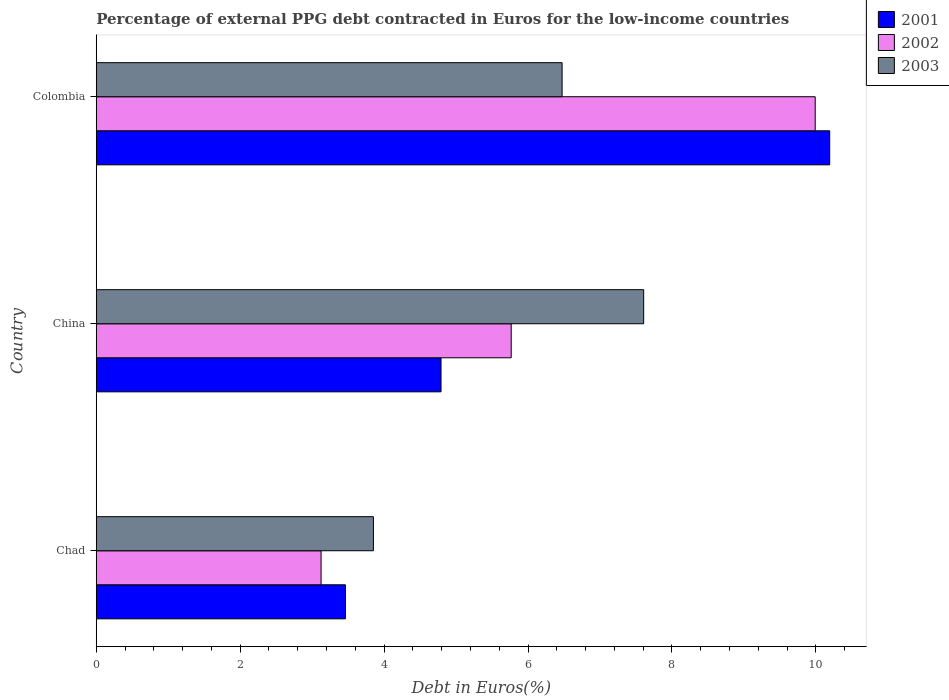Are the number of bars per tick equal to the number of legend labels?
Give a very brief answer. Yes. What is the label of the 1st group of bars from the top?
Give a very brief answer. Colombia. What is the percentage of external PPG debt contracted in Euros in 2003 in China?
Offer a terse response. 7.61. Across all countries, what is the maximum percentage of external PPG debt contracted in Euros in 2002?
Offer a very short reply. 9.99. Across all countries, what is the minimum percentage of external PPG debt contracted in Euros in 2001?
Your answer should be very brief. 3.46. In which country was the percentage of external PPG debt contracted in Euros in 2002 maximum?
Give a very brief answer. Colombia. In which country was the percentage of external PPG debt contracted in Euros in 2003 minimum?
Your response must be concise. Chad. What is the total percentage of external PPG debt contracted in Euros in 2002 in the graph?
Your response must be concise. 18.88. What is the difference between the percentage of external PPG debt contracted in Euros in 2003 in Chad and that in China?
Your answer should be very brief. -3.76. What is the difference between the percentage of external PPG debt contracted in Euros in 2003 in China and the percentage of external PPG debt contracted in Euros in 2002 in Colombia?
Provide a succinct answer. -2.38. What is the average percentage of external PPG debt contracted in Euros in 2003 per country?
Provide a succinct answer. 5.98. What is the difference between the percentage of external PPG debt contracted in Euros in 2002 and percentage of external PPG debt contracted in Euros in 2001 in China?
Your answer should be compact. 0.98. What is the ratio of the percentage of external PPG debt contracted in Euros in 2003 in Chad to that in Colombia?
Your answer should be very brief. 0.59. What is the difference between the highest and the second highest percentage of external PPG debt contracted in Euros in 2001?
Provide a succinct answer. 5.4. What is the difference between the highest and the lowest percentage of external PPG debt contracted in Euros in 2003?
Make the answer very short. 3.76. In how many countries, is the percentage of external PPG debt contracted in Euros in 2002 greater than the average percentage of external PPG debt contracted in Euros in 2002 taken over all countries?
Provide a short and direct response. 1. Is the sum of the percentage of external PPG debt contracted in Euros in 2002 in Chad and Colombia greater than the maximum percentage of external PPG debt contracted in Euros in 2003 across all countries?
Offer a very short reply. Yes. Is it the case that in every country, the sum of the percentage of external PPG debt contracted in Euros in 2001 and percentage of external PPG debt contracted in Euros in 2003 is greater than the percentage of external PPG debt contracted in Euros in 2002?
Provide a succinct answer. Yes. How many countries are there in the graph?
Provide a short and direct response. 3. What is the difference between two consecutive major ticks on the X-axis?
Make the answer very short. 2. Does the graph contain grids?
Ensure brevity in your answer.  No. Where does the legend appear in the graph?
Provide a succinct answer. Top right. What is the title of the graph?
Keep it short and to the point. Percentage of external PPG debt contracted in Euros for the low-income countries. What is the label or title of the X-axis?
Keep it short and to the point. Debt in Euros(%). What is the label or title of the Y-axis?
Provide a short and direct response. Country. What is the Debt in Euros(%) in 2001 in Chad?
Make the answer very short. 3.46. What is the Debt in Euros(%) in 2002 in Chad?
Your answer should be compact. 3.12. What is the Debt in Euros(%) of 2003 in Chad?
Keep it short and to the point. 3.85. What is the Debt in Euros(%) of 2001 in China?
Make the answer very short. 4.79. What is the Debt in Euros(%) in 2002 in China?
Provide a short and direct response. 5.77. What is the Debt in Euros(%) of 2003 in China?
Offer a very short reply. 7.61. What is the Debt in Euros(%) of 2001 in Colombia?
Make the answer very short. 10.19. What is the Debt in Euros(%) in 2002 in Colombia?
Give a very brief answer. 9.99. What is the Debt in Euros(%) in 2003 in Colombia?
Provide a succinct answer. 6.47. Across all countries, what is the maximum Debt in Euros(%) in 2001?
Your response must be concise. 10.19. Across all countries, what is the maximum Debt in Euros(%) in 2002?
Offer a terse response. 9.99. Across all countries, what is the maximum Debt in Euros(%) of 2003?
Give a very brief answer. 7.61. Across all countries, what is the minimum Debt in Euros(%) of 2001?
Your response must be concise. 3.46. Across all countries, what is the minimum Debt in Euros(%) in 2002?
Keep it short and to the point. 3.12. Across all countries, what is the minimum Debt in Euros(%) in 2003?
Make the answer very short. 3.85. What is the total Debt in Euros(%) in 2001 in the graph?
Your response must be concise. 18.44. What is the total Debt in Euros(%) in 2002 in the graph?
Keep it short and to the point. 18.88. What is the total Debt in Euros(%) of 2003 in the graph?
Provide a short and direct response. 17.93. What is the difference between the Debt in Euros(%) of 2001 in Chad and that in China?
Offer a very short reply. -1.33. What is the difference between the Debt in Euros(%) of 2002 in Chad and that in China?
Ensure brevity in your answer.  -2.64. What is the difference between the Debt in Euros(%) in 2003 in Chad and that in China?
Your answer should be compact. -3.76. What is the difference between the Debt in Euros(%) in 2001 in Chad and that in Colombia?
Offer a very short reply. -6.73. What is the difference between the Debt in Euros(%) in 2002 in Chad and that in Colombia?
Your response must be concise. -6.87. What is the difference between the Debt in Euros(%) of 2003 in Chad and that in Colombia?
Provide a succinct answer. -2.62. What is the difference between the Debt in Euros(%) of 2001 in China and that in Colombia?
Keep it short and to the point. -5.4. What is the difference between the Debt in Euros(%) of 2002 in China and that in Colombia?
Make the answer very short. -4.22. What is the difference between the Debt in Euros(%) in 2003 in China and that in Colombia?
Offer a very short reply. 1.13. What is the difference between the Debt in Euros(%) of 2001 in Chad and the Debt in Euros(%) of 2002 in China?
Give a very brief answer. -2.3. What is the difference between the Debt in Euros(%) in 2001 in Chad and the Debt in Euros(%) in 2003 in China?
Offer a very short reply. -4.14. What is the difference between the Debt in Euros(%) of 2002 in Chad and the Debt in Euros(%) of 2003 in China?
Make the answer very short. -4.48. What is the difference between the Debt in Euros(%) in 2001 in Chad and the Debt in Euros(%) in 2002 in Colombia?
Offer a very short reply. -6.53. What is the difference between the Debt in Euros(%) in 2001 in Chad and the Debt in Euros(%) in 2003 in Colombia?
Keep it short and to the point. -3.01. What is the difference between the Debt in Euros(%) of 2002 in Chad and the Debt in Euros(%) of 2003 in Colombia?
Make the answer very short. -3.35. What is the difference between the Debt in Euros(%) in 2001 in China and the Debt in Euros(%) in 2002 in Colombia?
Ensure brevity in your answer.  -5.2. What is the difference between the Debt in Euros(%) in 2001 in China and the Debt in Euros(%) in 2003 in Colombia?
Provide a short and direct response. -1.68. What is the difference between the Debt in Euros(%) in 2002 in China and the Debt in Euros(%) in 2003 in Colombia?
Make the answer very short. -0.71. What is the average Debt in Euros(%) of 2001 per country?
Your answer should be compact. 6.15. What is the average Debt in Euros(%) in 2002 per country?
Your answer should be very brief. 6.29. What is the average Debt in Euros(%) in 2003 per country?
Provide a succinct answer. 5.98. What is the difference between the Debt in Euros(%) in 2001 and Debt in Euros(%) in 2002 in Chad?
Your response must be concise. 0.34. What is the difference between the Debt in Euros(%) of 2001 and Debt in Euros(%) of 2003 in Chad?
Provide a succinct answer. -0.39. What is the difference between the Debt in Euros(%) in 2002 and Debt in Euros(%) in 2003 in Chad?
Offer a very short reply. -0.73. What is the difference between the Debt in Euros(%) in 2001 and Debt in Euros(%) in 2002 in China?
Give a very brief answer. -0.98. What is the difference between the Debt in Euros(%) in 2001 and Debt in Euros(%) in 2003 in China?
Your answer should be very brief. -2.82. What is the difference between the Debt in Euros(%) in 2002 and Debt in Euros(%) in 2003 in China?
Provide a succinct answer. -1.84. What is the difference between the Debt in Euros(%) in 2001 and Debt in Euros(%) in 2002 in Colombia?
Make the answer very short. 0.2. What is the difference between the Debt in Euros(%) in 2001 and Debt in Euros(%) in 2003 in Colombia?
Keep it short and to the point. 3.72. What is the difference between the Debt in Euros(%) of 2002 and Debt in Euros(%) of 2003 in Colombia?
Offer a terse response. 3.52. What is the ratio of the Debt in Euros(%) of 2001 in Chad to that in China?
Make the answer very short. 0.72. What is the ratio of the Debt in Euros(%) of 2002 in Chad to that in China?
Keep it short and to the point. 0.54. What is the ratio of the Debt in Euros(%) of 2003 in Chad to that in China?
Keep it short and to the point. 0.51. What is the ratio of the Debt in Euros(%) in 2001 in Chad to that in Colombia?
Your answer should be compact. 0.34. What is the ratio of the Debt in Euros(%) of 2002 in Chad to that in Colombia?
Your answer should be very brief. 0.31. What is the ratio of the Debt in Euros(%) of 2003 in Chad to that in Colombia?
Provide a succinct answer. 0.59. What is the ratio of the Debt in Euros(%) of 2001 in China to that in Colombia?
Keep it short and to the point. 0.47. What is the ratio of the Debt in Euros(%) of 2002 in China to that in Colombia?
Keep it short and to the point. 0.58. What is the ratio of the Debt in Euros(%) in 2003 in China to that in Colombia?
Make the answer very short. 1.18. What is the difference between the highest and the second highest Debt in Euros(%) of 2001?
Your answer should be very brief. 5.4. What is the difference between the highest and the second highest Debt in Euros(%) of 2002?
Your answer should be compact. 4.22. What is the difference between the highest and the second highest Debt in Euros(%) in 2003?
Your response must be concise. 1.13. What is the difference between the highest and the lowest Debt in Euros(%) of 2001?
Offer a terse response. 6.73. What is the difference between the highest and the lowest Debt in Euros(%) of 2002?
Ensure brevity in your answer.  6.87. What is the difference between the highest and the lowest Debt in Euros(%) of 2003?
Your answer should be compact. 3.76. 